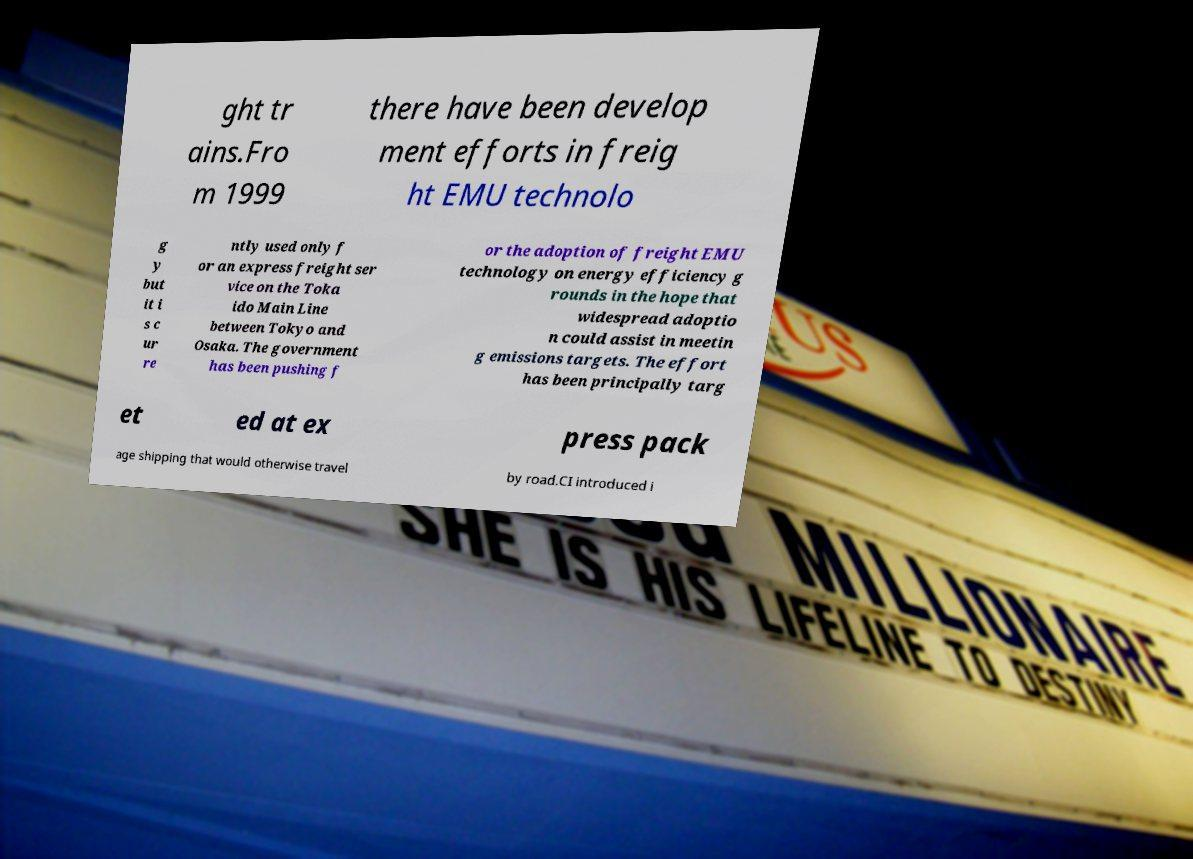I need the written content from this picture converted into text. Can you do that? ght tr ains.Fro m 1999 there have been develop ment efforts in freig ht EMU technolo g y but it i s c ur re ntly used only f or an express freight ser vice on the Toka ido Main Line between Tokyo and Osaka. The government has been pushing f or the adoption of freight EMU technology on energy efficiency g rounds in the hope that widespread adoptio n could assist in meetin g emissions targets. The effort has been principally targ et ed at ex press pack age shipping that would otherwise travel by road.CI introduced i 